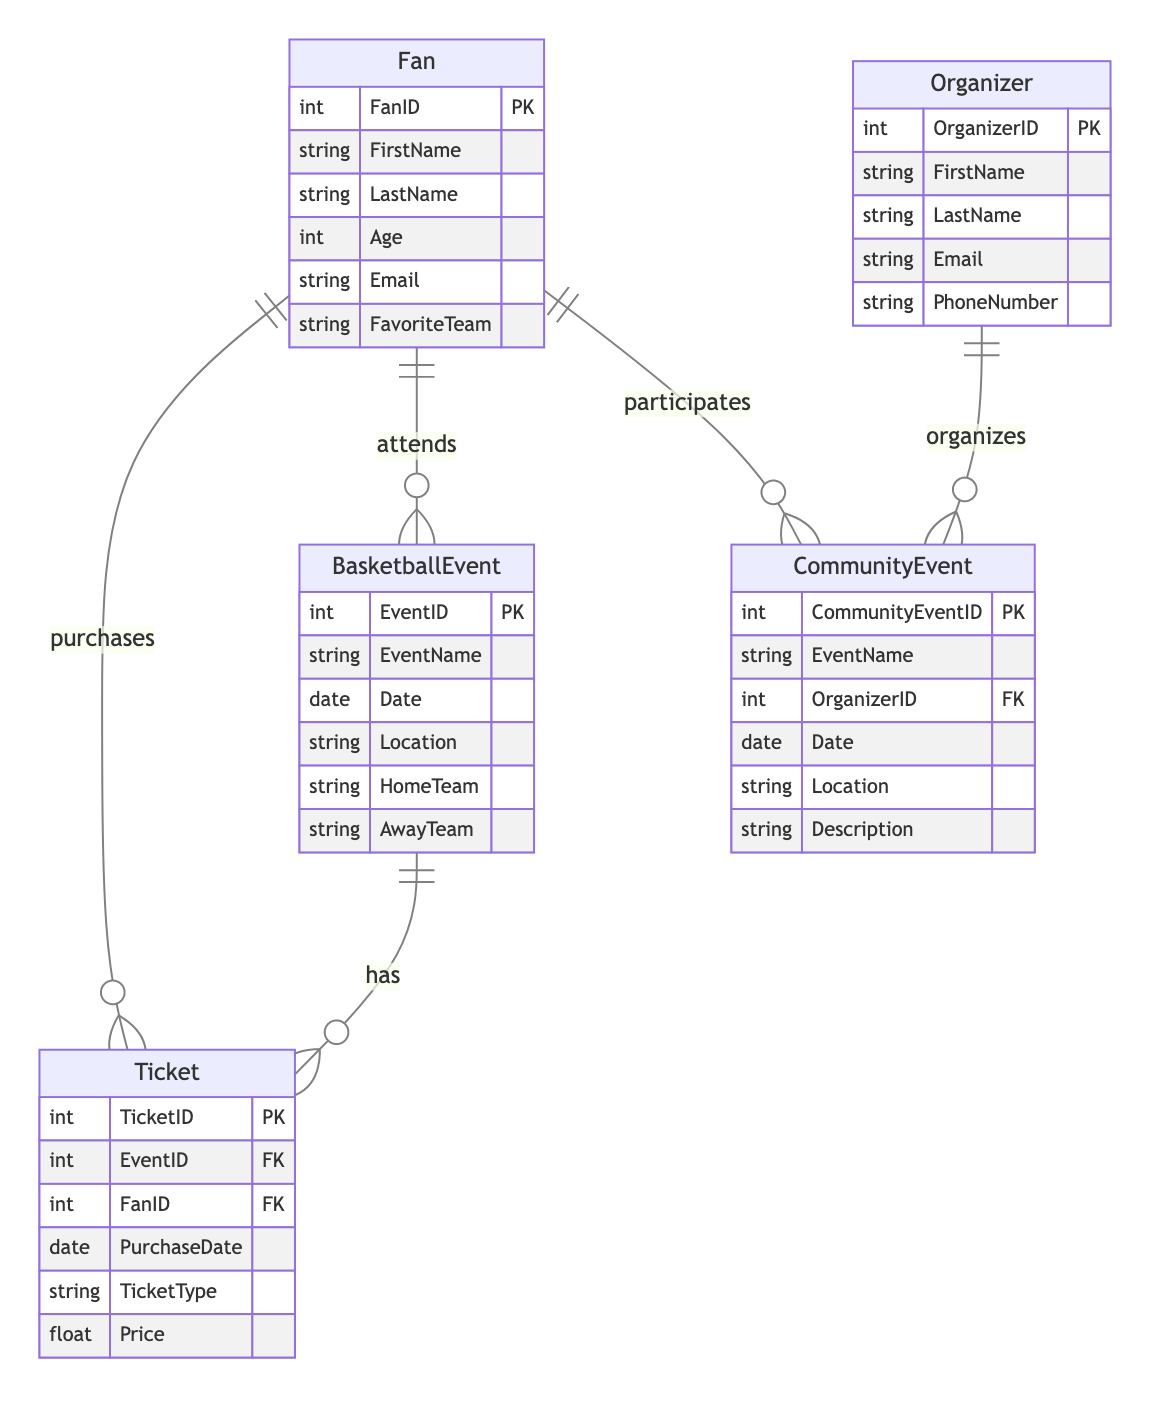What is the primary key of the Fan entity? The primary key of the Fan entity is indicated by "PK," which denotes the FanID attribute. This means FanID uniquely identifies each fan in the database.
Answer: FanID How many entities are in the diagram? To determine the number of entities, we count the unique entities listed: Fan, BasketballEvent, Ticket, CommunityEvent, and Organizer, which totals five entities.
Answer: 5 What relationship connects Fan and BasketballEvent? The relationship indicated between Fan and BasketballEvent is labeled "attends," connecting fans who attend basketball events. This relationship specifies that fans are associated with the events they attend through tickets.
Answer: attends What does TicketID represent in the Ticket entity? TicketID serves as the primary identifier for entries in the Ticket entity, indicated by "PK." This means each ticket sold for an event has a unique TicketID.
Answer: TicketID Which entity is responsible for organizing CommunityEvents? The Organizer entity is responsible for organizing CommunityEvents, as shown by the "organizes" relationship linking Organizer to CommunityEvent, indicating that organizers manage these events.
Answer: Organizer What information is needed to participate in a CommunityEvent? To participate in a CommunityEvent, the attributes necessary are FanID and CommunityEventID, as indicated in the participation relationship. This means both the fan's identifier and the event's identifier are essential for participation record keeping.
Answer: FanID, CommunityEventID What is the purpose of the Ticket entity in this diagram? The Ticket entity serves to record the details of tickets purchased for BasketballEvents, including purchase date, type, and price, as well as linking fans to specific events. This relational function helps maintain a record of fan attendance and ticket sales.
Answer: Record tickets purchased How many attributes does the CommunityEvent entity have? Counting the listed attributes of the CommunityEvent entity, we see the following: CommunityEventID, EventName, OrganizerID, Date, Location, and Description, which totals six attributes.
Answer: 6 What type of relationship exists between Fan and CommunityEvent? The relationship between Fan and CommunityEvent is labeled "participates," indicating that fans can take part in community events. This relationship allows tracking of fans’ engagement with various community initiatives.
Answer: participates 